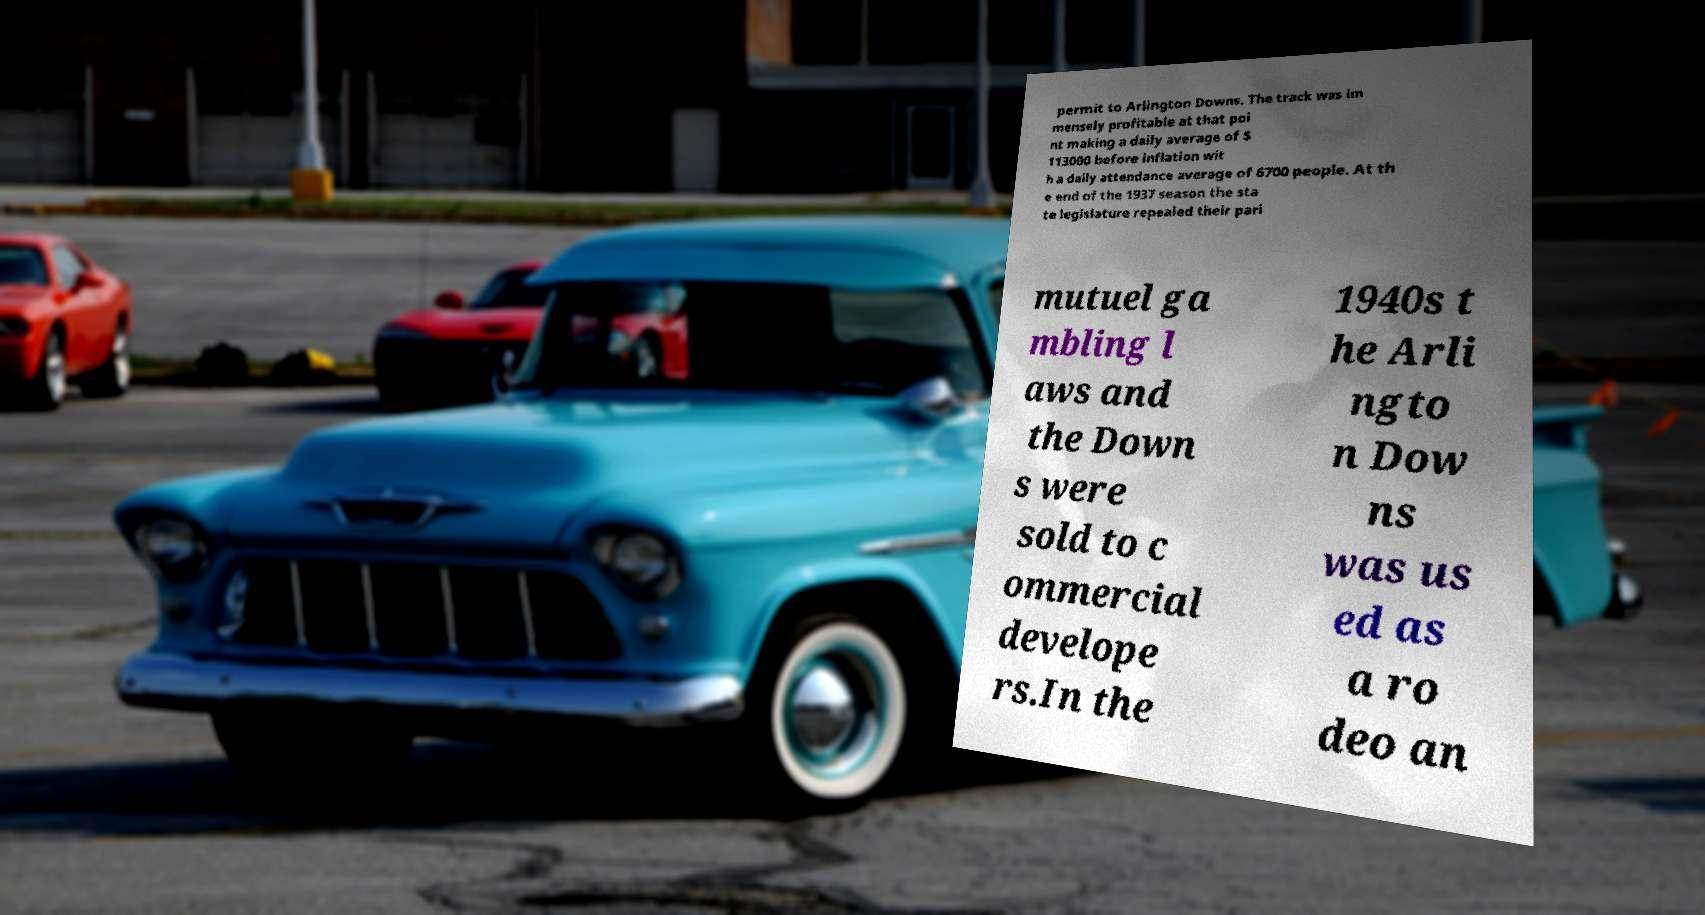For documentation purposes, I need the text within this image transcribed. Could you provide that? permit to Arlington Downs. The track was im mensely profitable at that poi nt making a daily average of $ 113000 before inflation wit h a daily attendance average of 6700 people. At th e end of the 1937 season the sta te legislature repealed their pari mutuel ga mbling l aws and the Down s were sold to c ommercial develope rs.In the 1940s t he Arli ngto n Dow ns was us ed as a ro deo an 